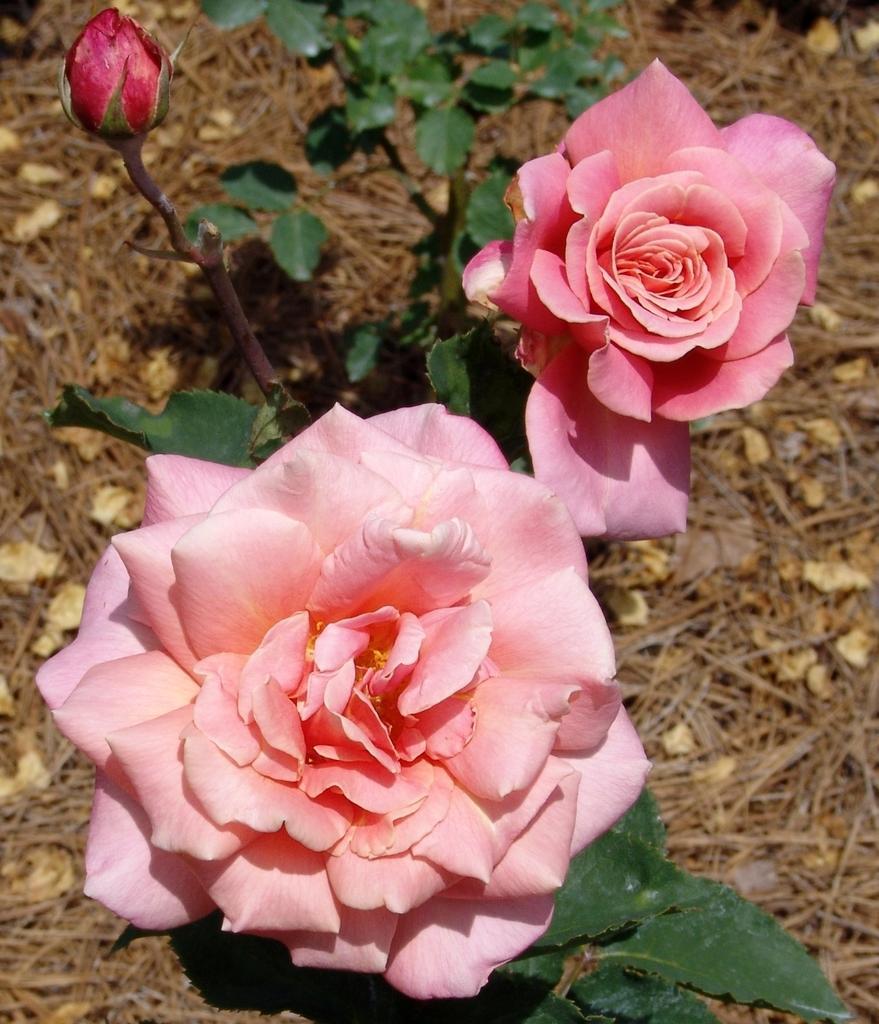Please provide a concise description of this image. In this picture we can see two rose flowers and leaves in the front, at the bottom there is some grass and leaves. 